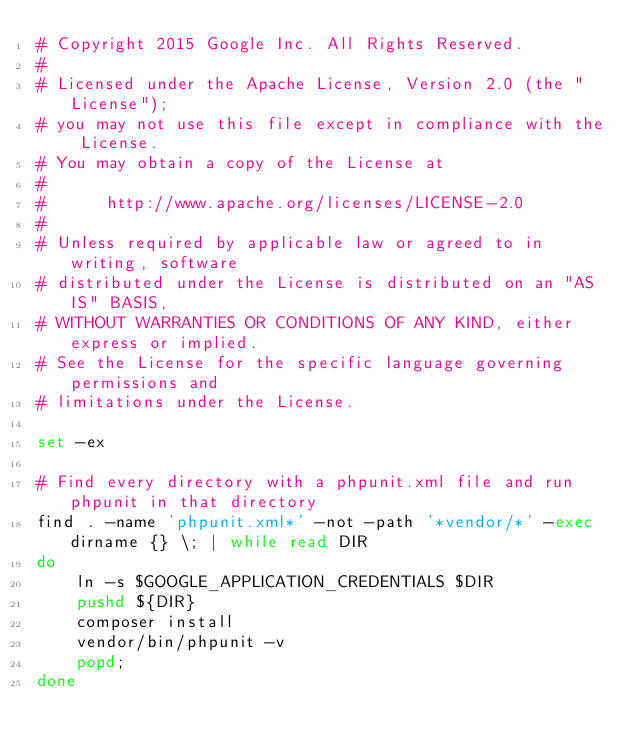<code> <loc_0><loc_0><loc_500><loc_500><_Bash_># Copyright 2015 Google Inc. All Rights Reserved.
#
# Licensed under the Apache License, Version 2.0 (the "License");
# you may not use this file except in compliance with the License.
# You may obtain a copy of the License at
#
#      http://www.apache.org/licenses/LICENSE-2.0
#
# Unless required by applicable law or agreed to in writing, software
# distributed under the License is distributed on an "AS IS" BASIS,
# WITHOUT WARRANTIES OR CONDITIONS OF ANY KIND, either express or implied.
# See the License for the specific language governing permissions and
# limitations under the License.

set -ex

# Find every directory with a phpunit.xml file and run phpunit in that directory
find . -name 'phpunit.xml*' -not -path '*vendor/*' -exec dirname {} \; | while read DIR
do
    ln -s $GOOGLE_APPLICATION_CREDENTIALS $DIR
    pushd ${DIR}
    composer install
    vendor/bin/phpunit -v
    popd;
done
</code> 